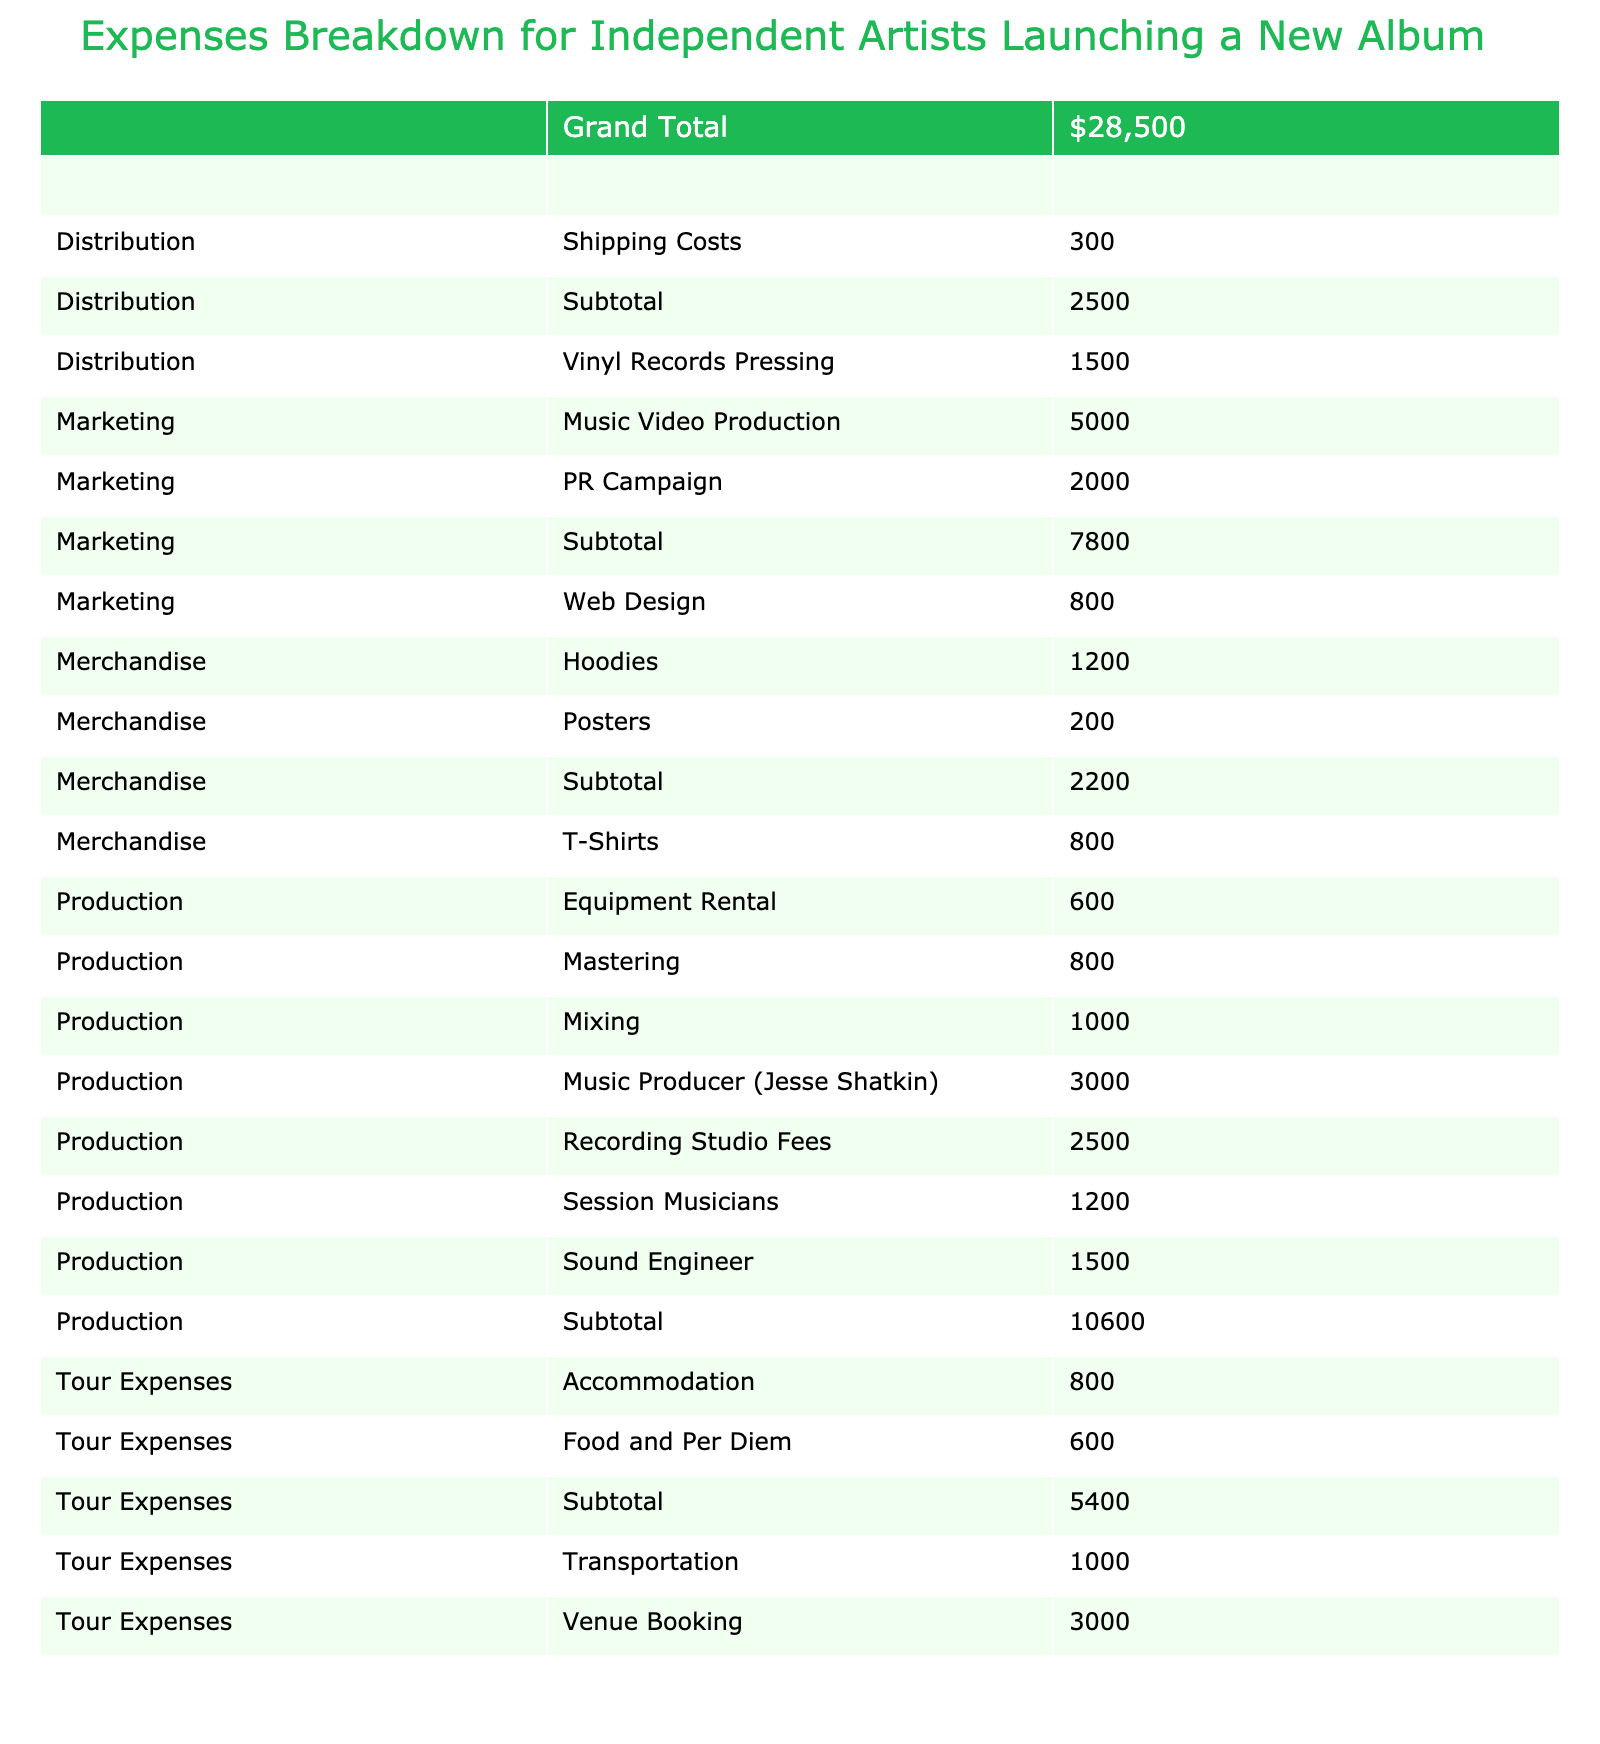What's the total cost of Production expenses? The Production category includes the following costs: Recording Studio Fees (2500), Music Producer (Jesse Shatkin) (3000), Session Musicians (1200), Sound Engineer (1500), Mastering (800), Mixing (1000), and Equipment Rental (600). I will sum these amounts: 2500 + 3000 + 1200 + 1500 + 800 + 1000 + 600 = 10300.
Answer: 10300 What is the cost of Marketing compared to Tour Expenses? The Marketing category includes Music Video Production (5000), PR Campaign (2000), and Web Design (800) which totals 6800 (5000 + 2000 + 800). The Tour Expenses include Venue Booking (3000), Transportation (1000), Accommodation (800), and Food and Per Diem (600), summing up to 5400 (3000 + 1000 + 800 + 600). Thus, Marketing costs are higher than Tour Expenses, specifically by 6800 - 5400 = 1400.
Answer: Marketing costs 1400 more What are the total costs of Merchandising items? The Merchandise category has T-Shirts (800), Hoodies (1200), and Posters (200). Adding these amounts gives us: 800 + 1200 + 200 = 2200.
Answer: 2200 Is the cost of physical CDs duplication higher than the costs of session musicians? The cost for the Physical CDs Duplication is 700 and for Session Musicians it is 1200. Since 700 is less than 1200, the answer is no, it is not higher.
Answer: No What is the combined total of Production and Distribution expenses? The total Production expenses are 10300 (calculated previously). The Distribution expenses are Physical CDs Duplication (700), Vinyl Records Pressing (1500), and Shipping Costs (300), totaling 2500 (700 + 1500 + 300). The combined total is 10300 + 2500 = 12800.
Answer: 12800 What is the average cost of Merchandising items? The Merchandising category includes three items: T-Shirts (800), Hoodies (1200), and Posters (200). Summing these gives: 800 + 1200 + 200 = 2200. To find the average, divide by the number of items: 2200 / 3 = approximately 733.33 when rounded.
Answer: Approximately 733.33 How much is spent on Marketing video production? The cost of Music Video Production in the Marketing category is specifically listed as 5000.
Answer: 5000 Which category has the highest total cost? From the analysis of each category's total costs: Production is 10300, Marketing is 6800, Distribution is 2500, Merchandise is 2200, and Tour Expenses is 5400. Production has the highest total at 10300.
Answer: Production 